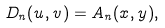<formula> <loc_0><loc_0><loc_500><loc_500>D _ { n } ( u , v ) = A _ { n } ( x , y ) ,</formula> 